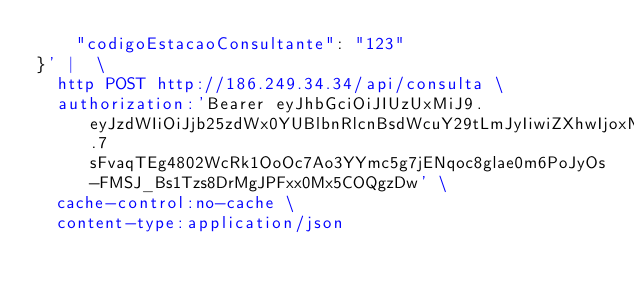Convert code to text. <code><loc_0><loc_0><loc_500><loc_500><_Bash_>    "codigoEstacaoConsultante": "123"
}' |  \
  http POST http://186.249.34.34/api/consulta \
  authorization:'Bearer eyJhbGciOiJIUzUxMiJ9.eyJzdWIiOiJjb25zdWx0YUBlbnRlcnBsdWcuY29tLmJyIiwiZXhwIjoxNDcxMDk0ODAyfQ.7sFvaqTEg4802WcRk1OoOc7Ao3YYmc5g7jENqoc8glae0m6PoJyOs-FMSJ_Bs1Tzs8DrMgJPFxx0Mx5COQgzDw' \
  cache-control:no-cache \
  content-type:application/json
</code> 